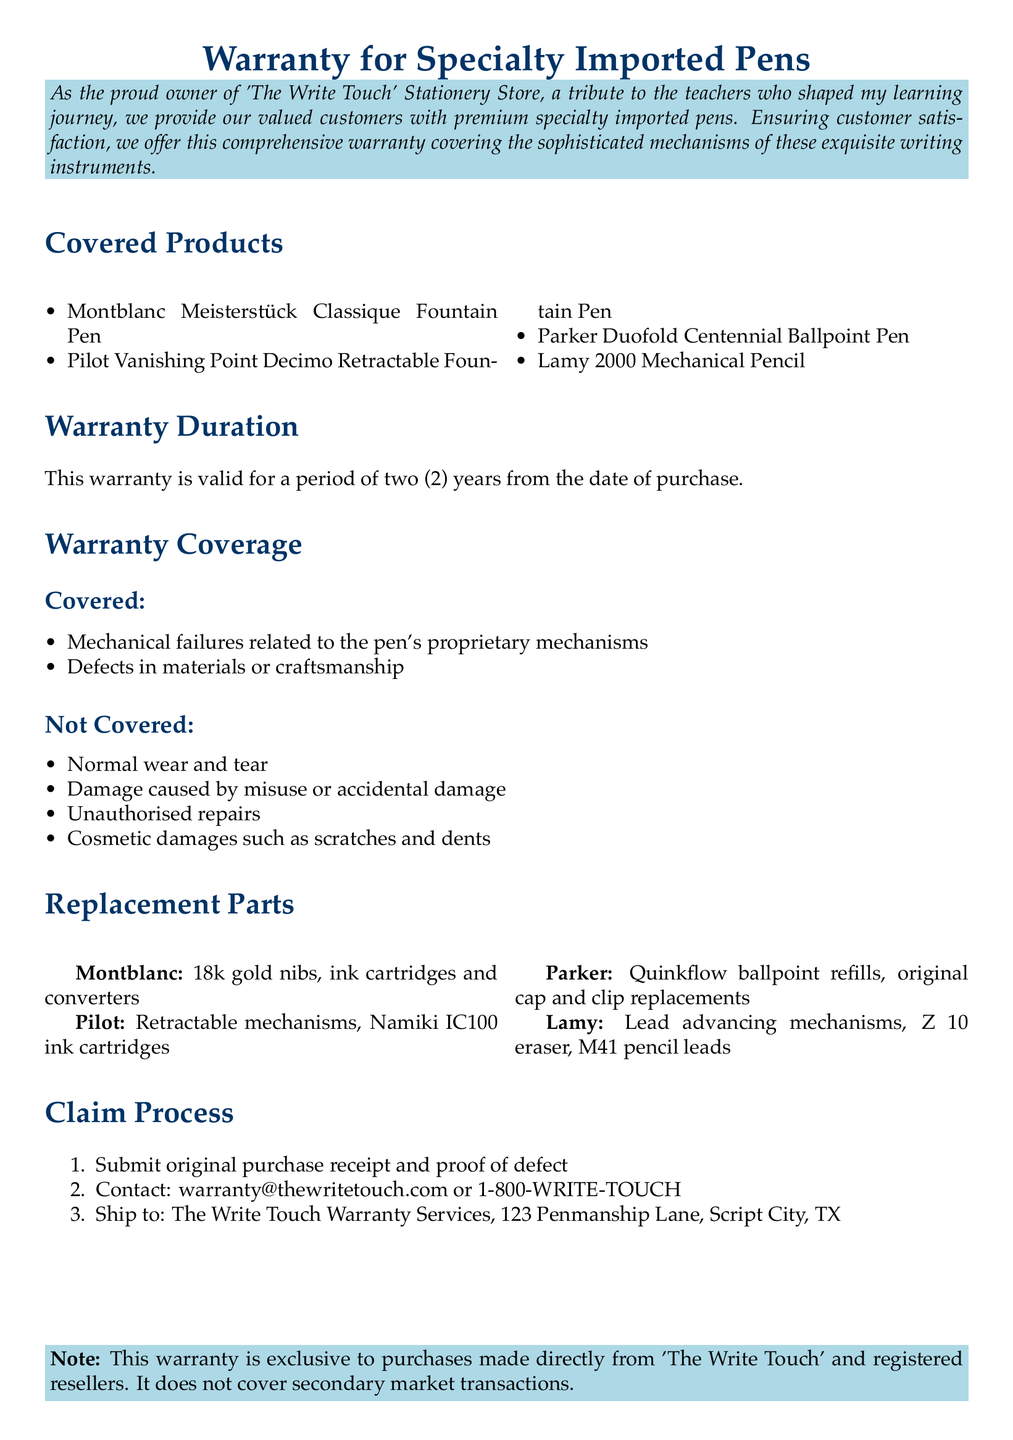What is the warranty duration? The warranty duration is specified in the document, which states it is valid for a period of two years from the date of purchase.
Answer: two years Which products are covered? The covered products are listed in the document, specifying the specialty imported pens.
Answer: Montblanc Meisterstück Classique Fountain Pen, Pilot Vanishing Point Decimo Retractable Fountain Pen, Parker Duofold Centennial Ballpoint Pen, Lamy 2000 Mechanical Pencil What defects are covered under the warranty? The document outlines the coverage under the warranty, which includes specific failures and defects.
Answer: Mechanical failures related to the pen's proprietary mechanisms, Defects in materials or craftsmanship What is not covered by the warranty? The document provides specific exclusions from the warranty coverage for clarity on what is not included.
Answer: Normal wear and tear, Damage caused by misuse or accidental damage, Unauthorised repairs, Cosmetic damages such as scratches and dents How can a claim be submitted? The document details the claim process and steps for customers to follow if they encounter a defect.
Answer: Submit original purchase receipt and proof of defect What is the contact email for warranty claims? The document includes a specific email address for customers to contact regarding warranty claims.
Answer: warranty@thewritetouch.com Where should the warranty claims be shipped? The shipping address for warranty claims is specified in the document for customer reference.
Answer: The Write Touch Warranty Services, 123 Penmanship Lane, Script City, TX 